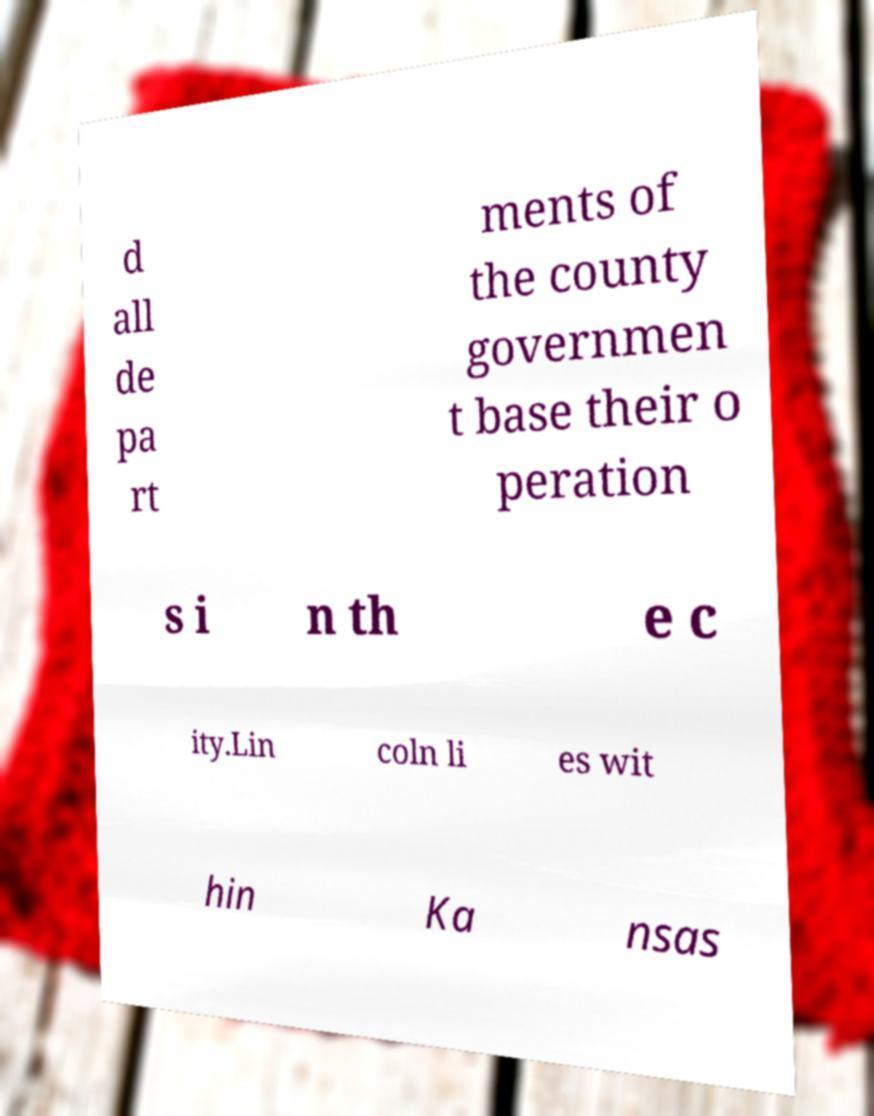There's text embedded in this image that I need extracted. Can you transcribe it verbatim? d all de pa rt ments of the county governmen t base their o peration s i n th e c ity.Lin coln li es wit hin Ka nsas 